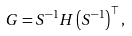Convert formula to latex. <formula><loc_0><loc_0><loc_500><loc_500>G & = S ^ { - 1 } H \left ( S ^ { - 1 } \right ) ^ { \top } ,</formula> 